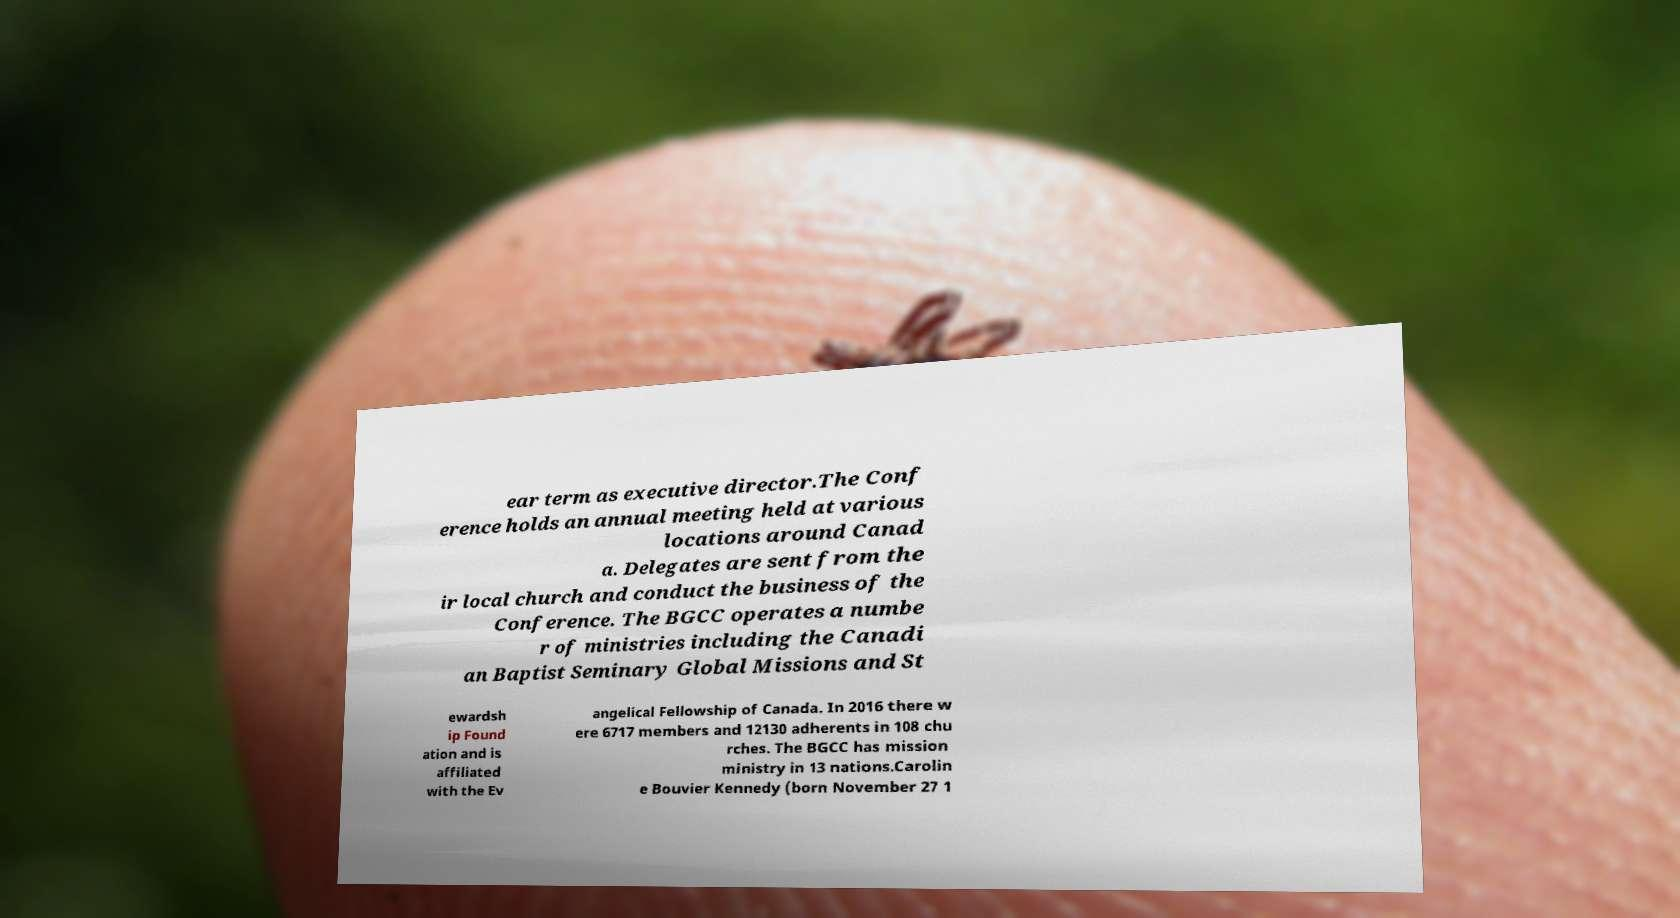Can you accurately transcribe the text from the provided image for me? ear term as executive director.The Conf erence holds an annual meeting held at various locations around Canad a. Delegates are sent from the ir local church and conduct the business of the Conference. The BGCC operates a numbe r of ministries including the Canadi an Baptist Seminary Global Missions and St ewardsh ip Found ation and is affiliated with the Ev angelical Fellowship of Canada. In 2016 there w ere 6717 members and 12130 adherents in 108 chu rches. The BGCC has mission ministry in 13 nations.Carolin e Bouvier Kennedy (born November 27 1 